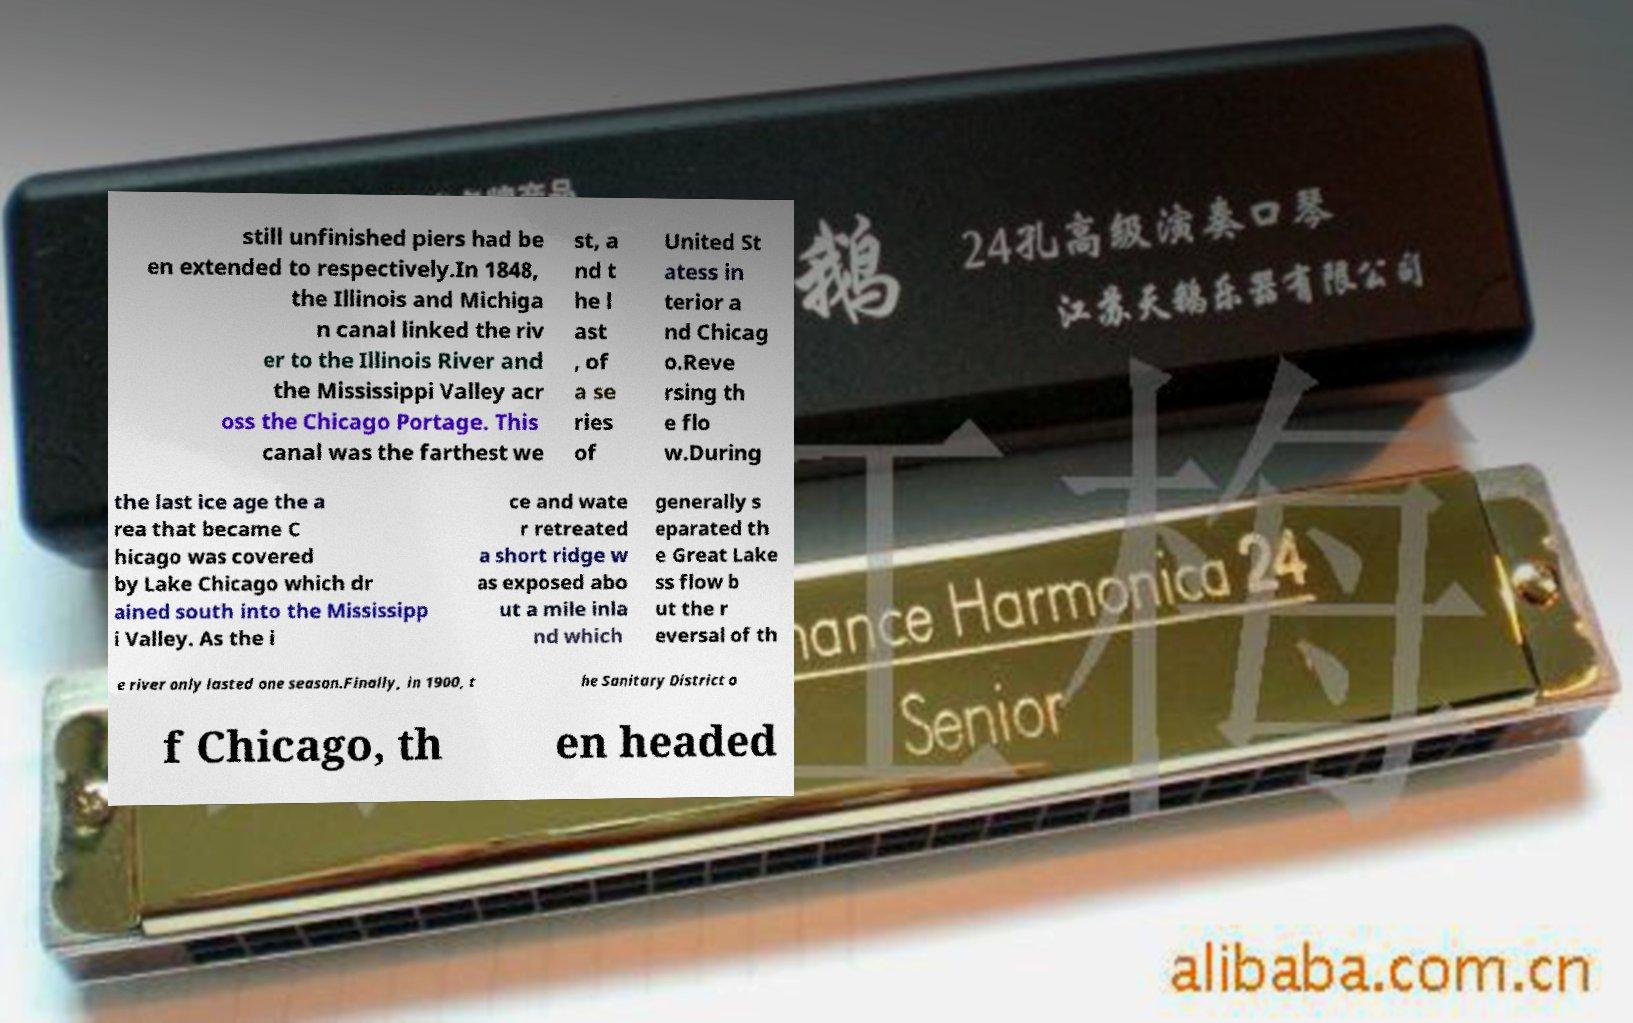For documentation purposes, I need the text within this image transcribed. Could you provide that? still unfinished piers had be en extended to respectively.In 1848, the Illinois and Michiga n canal linked the riv er to the Illinois River and the Mississippi Valley acr oss the Chicago Portage. This canal was the farthest we st, a nd t he l ast , of a se ries of United St atess in terior a nd Chicag o.Reve rsing th e flo w.During the last ice age the a rea that became C hicago was covered by Lake Chicago which dr ained south into the Mississipp i Valley. As the i ce and wate r retreated a short ridge w as exposed abo ut a mile inla nd which generally s eparated th e Great Lake ss flow b ut the r eversal of th e river only lasted one season.Finally, in 1900, t he Sanitary District o f Chicago, th en headed 